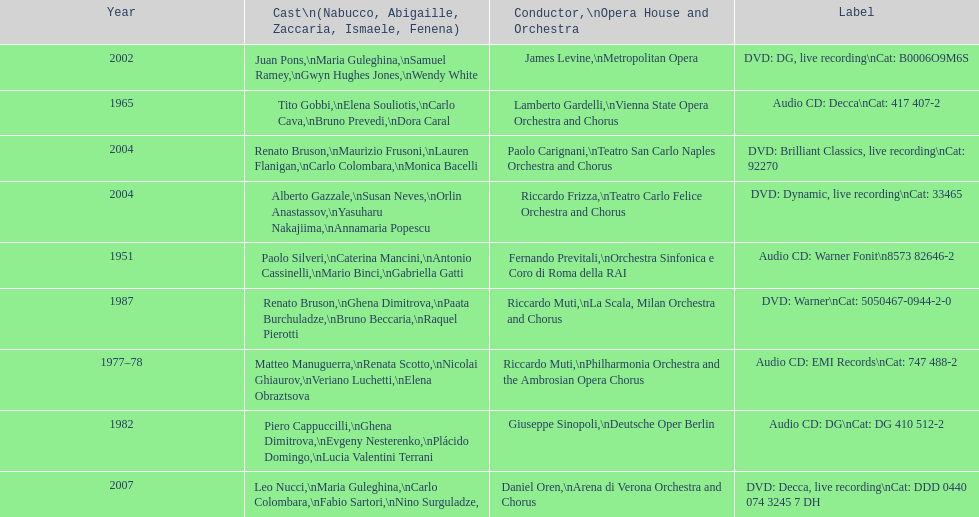How many recordings of nabucco have been made? 9. Would you be able to parse every entry in this table? {'header': ['Year', 'Cast\\n(Nabucco, Abigaille, Zaccaria, Ismaele, Fenena)', 'Conductor,\\nOpera House and Orchestra', 'Label'], 'rows': [['2002', 'Juan Pons,\\nMaria Guleghina,\\nSamuel Ramey,\\nGwyn Hughes Jones,\\nWendy White', 'James Levine,\\nMetropolitan Opera', 'DVD: DG, live recording\\nCat: B0006O9M6S'], ['1965', 'Tito Gobbi,\\nElena Souliotis,\\nCarlo Cava,\\nBruno Prevedi,\\nDora Caral', 'Lamberto Gardelli,\\nVienna State Opera Orchestra and Chorus', 'Audio CD: Decca\\nCat: 417 407-2'], ['2004', 'Renato Bruson,\\nMaurizio Frusoni,\\nLauren Flanigan,\\nCarlo Colombara,\\nMonica Bacelli', 'Paolo Carignani,\\nTeatro San Carlo Naples Orchestra and Chorus', 'DVD: Brilliant Classics, live recording\\nCat: 92270'], ['2004', 'Alberto Gazzale,\\nSusan Neves,\\nOrlin Anastassov,\\nYasuharu Nakajiima,\\nAnnamaria Popescu', 'Riccardo Frizza,\\nTeatro Carlo Felice Orchestra and Chorus', 'DVD: Dynamic, live recording\\nCat: 33465'], ['1951', 'Paolo Silveri,\\nCaterina Mancini,\\nAntonio Cassinelli,\\nMario Binci,\\nGabriella Gatti', 'Fernando Previtali,\\nOrchestra Sinfonica e Coro di Roma della RAI', 'Audio CD: Warner Fonit\\n8573 82646-2'], ['1987', 'Renato Bruson,\\nGhena Dimitrova,\\nPaata Burchuladze,\\nBruno Beccaria,\\nRaquel Pierotti', 'Riccardo Muti,\\nLa Scala, Milan Orchestra and Chorus', 'DVD: Warner\\nCat: 5050467-0944-2-0'], ['1977–78', 'Matteo Manuguerra,\\nRenata Scotto,\\nNicolai Ghiaurov,\\nVeriano Luchetti,\\nElena Obraztsova', 'Riccardo Muti,\\nPhilharmonia Orchestra and the Ambrosian Opera Chorus', 'Audio CD: EMI Records\\nCat: 747 488-2'], ['1982', 'Piero Cappuccilli,\\nGhena Dimitrova,\\nEvgeny Nesterenko,\\nPlácido Domingo,\\nLucia Valentini Terrani', 'Giuseppe Sinopoli,\\nDeutsche Oper Berlin', 'Audio CD: DG\\nCat: DG 410 512-2'], ['2007', 'Leo Nucci,\\nMaria Guleghina,\\nCarlo Colombara,\\nFabio Sartori,\\nNino Surguladze,', 'Daniel Oren,\\nArena di Verona Orchestra and Chorus', 'DVD: Decca, live recording\\nCat: DDD 0440 074 3245 7 DH']]} 